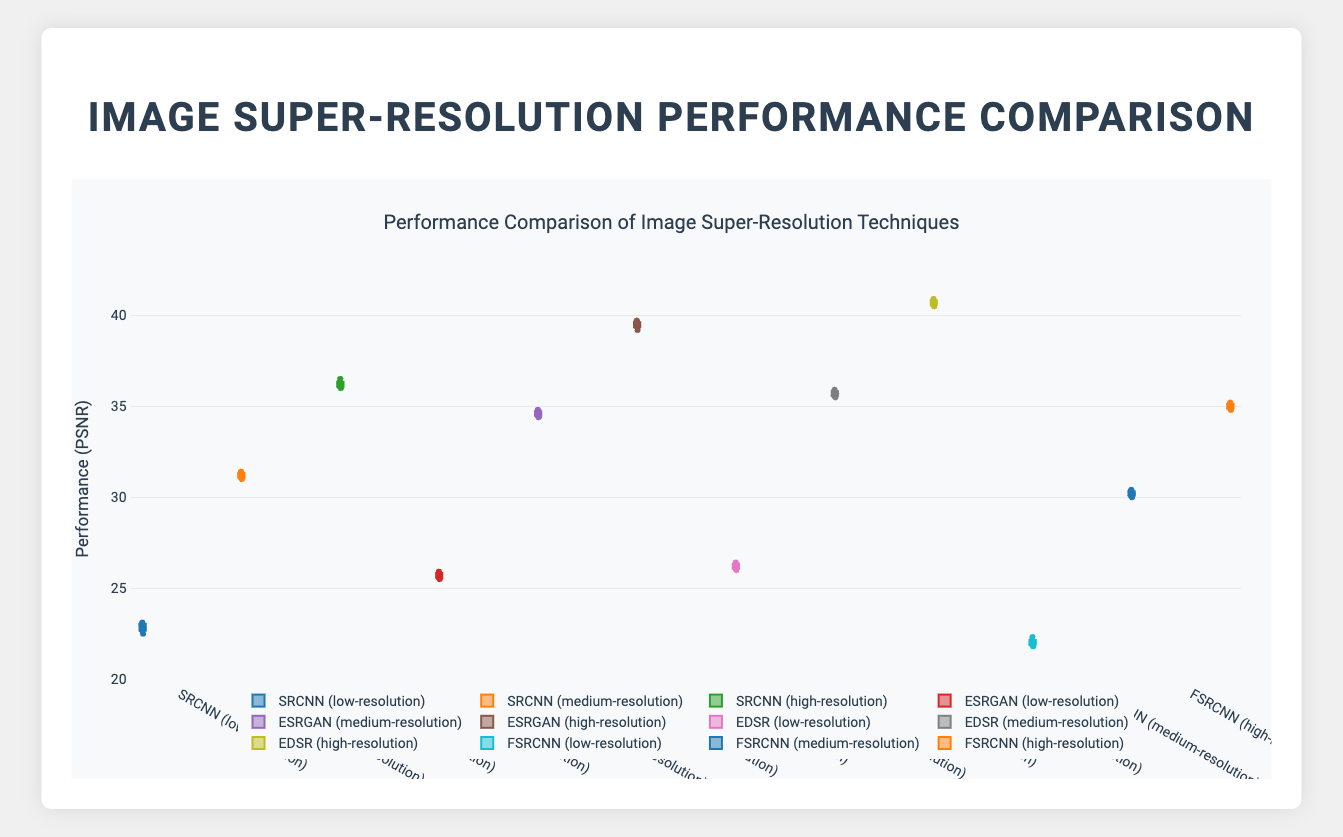Which technique has the highest performance score for high-resolution images? Look for the box plot groups labeled with high-resolution images and identify the technique with the highest median or upper outlier.
Answer: EDSR Which image quality has the lowest performance using the FSRCNN technique? Compare the median lines of FSRCNN box plots for low, medium, and high-resolution categories.
Answer: Low-resolution What's the range of performance scores for SRCNN on high-resolution images? Find the minimum and maximum values in the high-resolution SRCNN box plot.
Answer: 36.0 to 36.5 Which technique has a median performance score closest to 35 for medium-resolution images? Check the median lines of the box plots for all techniques under medium-resolution. Identify the one near 35.
Answer: EDSR What is the interquartile range (IQR) of ESRGAN for high-resolution images? Calculate the difference between the upper (Q3) and lower (Q1) quartiles in the high-resolution ESRGAN box plot.
Answer: (39.7 - 39.2) = 0.5 How does the performance of EDSR compare to ESRGAN for low-resolution images? Compare the median lines and the spread of the box plots for EDSR and ESRGAN in the low-resolution category.
Answer: EDSR has a higher median performance than ESRGAN Which technique shows the most consistent performance across all image qualities? Identify the technique with the smallest spread (shorter boxes) across all its box plots.
Answer: ESRGAN Among the techniques, which one shows the greatest improvement from low-resolution to high-resolution? Calculate the difference in median performance for each technique from low-resolution to high-resolution and compare.
Answer: EDSR Is there any technique that shows overlapping performance ranges for different image qualities? Look for box plots of the same technique that have overlapping boxes across different image qualities.
Answer: SRCNN (overlaps between medium and high-resolution) What is the average performance score for SRCNN across all image qualities? Sum the median performance scores of SRCNN for low, medium, and high-resolution and divide by 3.
Answer: (22.8 + 31.1 + 36.2) / 3 = 30.03 